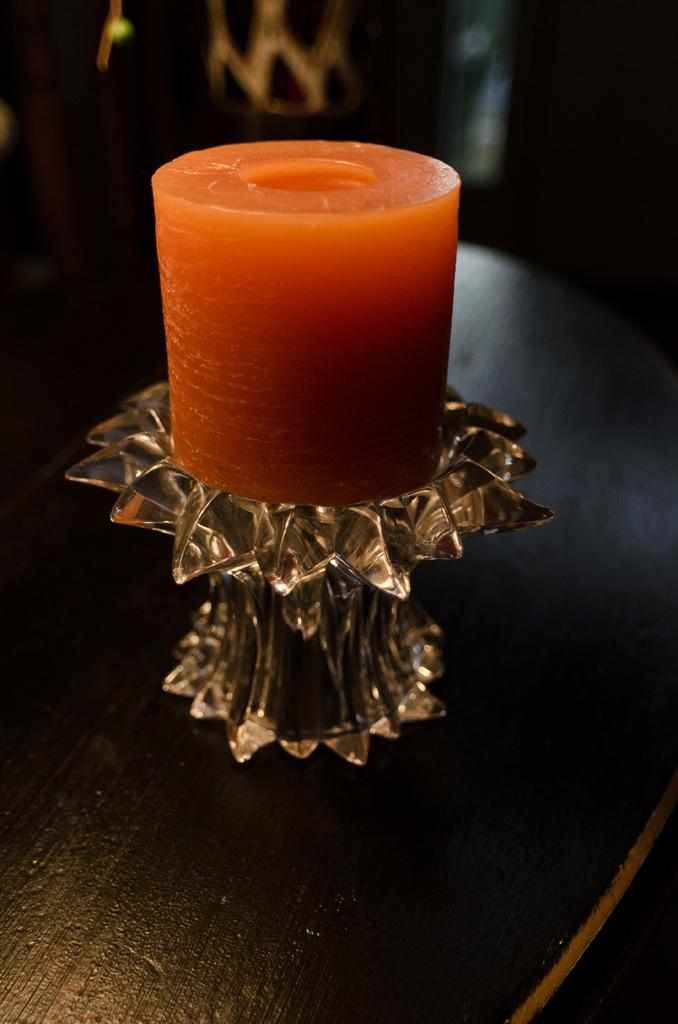What type of candle is on the glass stand in the image? There is an orange wax candle on a glass stand in the image. Where is the candle placed in the image? The candle is on a platform in the image. What can be observed about the lighting in the image? The remaining portion of the image is dark. What type of doctor is present in the image? There is no doctor present in the image; it only features an orange wax candle on a glass stand. What is the candle's mindset in the image? Candles do not have minds or mindsets, so this question cannot be answered. 